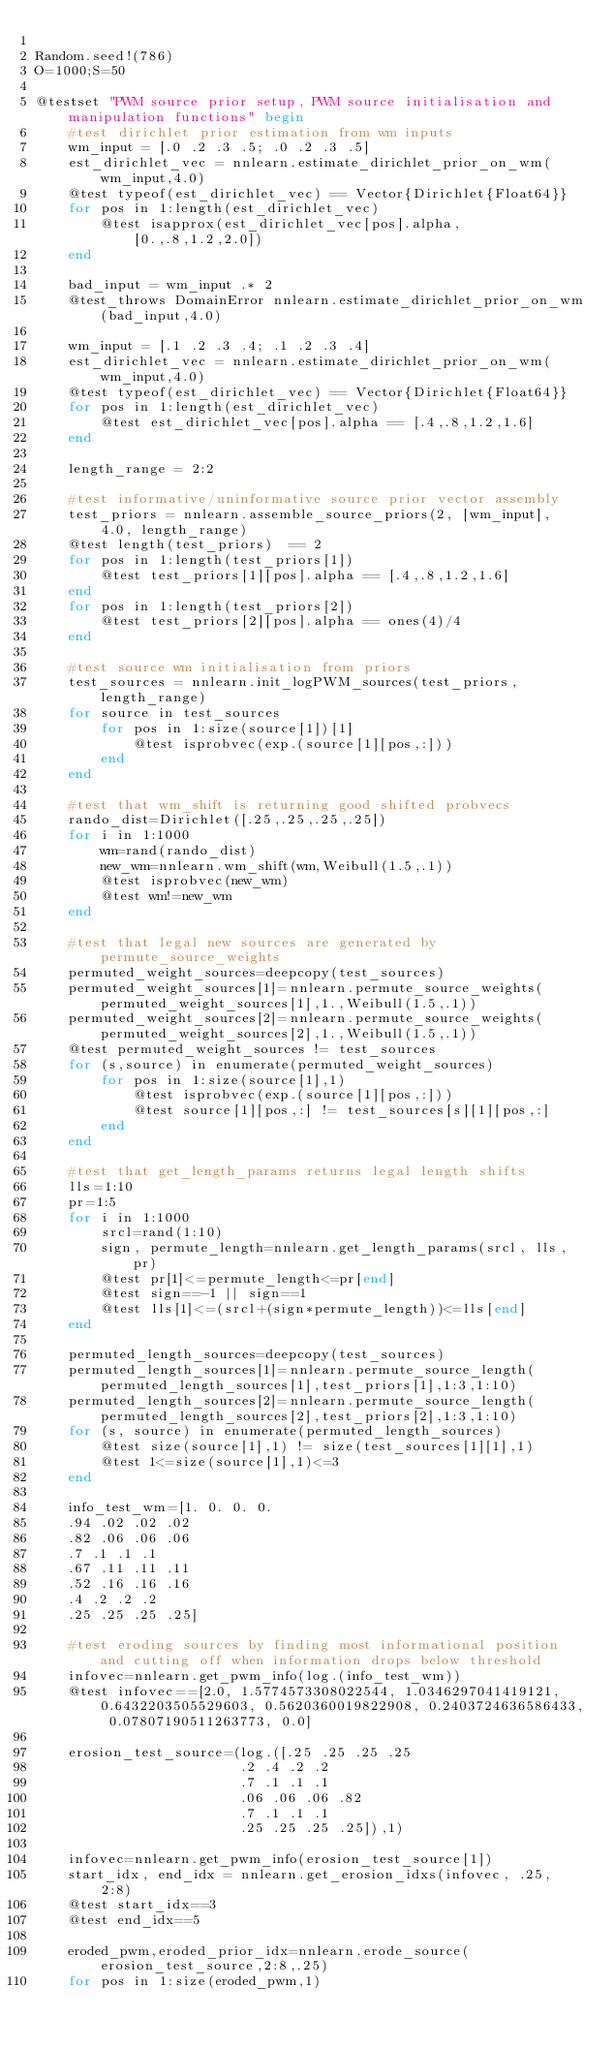<code> <loc_0><loc_0><loc_500><loc_500><_Julia_>
Random.seed!(786)
O=1000;S=50

@testset "PWM source prior setup, PWM source initialisation and manipulation functions" begin
    #test dirichlet prior estimation from wm inputs
    wm_input = [.0 .2 .3 .5; .0 .2 .3 .5]
    est_dirichlet_vec = nnlearn.estimate_dirichlet_prior_on_wm(wm_input,4.0)
    @test typeof(est_dirichlet_vec) == Vector{Dirichlet{Float64}}
    for pos in 1:length(est_dirichlet_vec)
        @test isapprox(est_dirichlet_vec[pos].alpha, [0.,.8,1.2,2.0])
    end

    bad_input = wm_input .* 2
    @test_throws DomainError nnlearn.estimate_dirichlet_prior_on_wm(bad_input,4.0)

    wm_input = [.1 .2 .3 .4; .1 .2 .3 .4]
    est_dirichlet_vec = nnlearn.estimate_dirichlet_prior_on_wm(wm_input,4.0)
    @test typeof(est_dirichlet_vec) == Vector{Dirichlet{Float64}}
    for pos in 1:length(est_dirichlet_vec)
        @test est_dirichlet_vec[pos].alpha == [.4,.8,1.2,1.6]
    end

    length_range = 2:2

    #test informative/uninformative source prior vector assembly
    test_priors = nnlearn.assemble_source_priors(2, [wm_input], 4.0, length_range)
    @test length(test_priors)  == 2
    for pos in 1:length(test_priors[1])
        @test test_priors[1][pos].alpha == [.4,.8,1.2,1.6]
    end
    for pos in 1:length(test_priors[2])
        @test test_priors[2][pos].alpha == ones(4)/4
    end

    #test source wm initialisation from priors
    test_sources = nnlearn.init_logPWM_sources(test_priors, length_range)
    for source in test_sources
        for pos in 1:size(source[1])[1]
            @test isprobvec(exp.(source[1][pos,:]))
        end
    end

    #test that wm_shift is returning good shifted probvecs
    rando_dist=Dirichlet([.25,.25,.25,.25])
    for i in 1:1000
        wm=rand(rando_dist)
        new_wm=nnlearn.wm_shift(wm,Weibull(1.5,.1))
        @test isprobvec(new_wm)
        @test wm!=new_wm
    end

    #test that legal new sources are generated by permute_source_weights
    permuted_weight_sources=deepcopy(test_sources)
    permuted_weight_sources[1]=nnlearn.permute_source_weights(permuted_weight_sources[1],1.,Weibull(1.5,.1))
    permuted_weight_sources[2]=nnlearn.permute_source_weights(permuted_weight_sources[2],1.,Weibull(1.5,.1))
    @test permuted_weight_sources != test_sources
    for (s,source) in enumerate(permuted_weight_sources)
        for pos in 1:size(source[1],1)
            @test isprobvec(exp.(source[1][pos,:]))
            @test source[1][pos,:] != test_sources[s][1][pos,:]
        end
    end

    #test that get_length_params returns legal length shifts
    lls=1:10
    pr=1:5
    for i in 1:1000
        srcl=rand(1:10)
        sign, permute_length=nnlearn.get_length_params(srcl, lls, pr)
        @test pr[1]<=permute_length<=pr[end]
        @test sign==-1 || sign==1
        @test lls[1]<=(srcl+(sign*permute_length))<=lls[end]
    end

    permuted_length_sources=deepcopy(test_sources)
    permuted_length_sources[1]=nnlearn.permute_source_length(permuted_length_sources[1],test_priors[1],1:3,1:10)
    permuted_length_sources[2]=nnlearn.permute_source_length(permuted_length_sources[2],test_priors[2],1:3,1:10)
    for (s, source) in enumerate(permuted_length_sources)
        @test size(source[1],1) != size(test_sources[1][1],1)
        @test 1<=size(source[1],1)<=3
    end

    info_test_wm=[1. 0. 0. 0.
    .94 .02 .02 .02
    .82 .06 .06 .06
    .7 .1 .1 .1
    .67 .11 .11 .11
    .52 .16 .16 .16
    .4 .2 .2 .2
    .25 .25 .25 .25]

    #test eroding sources by finding most informational position and cutting off when information drops below threshold
    infovec=nnlearn.get_pwm_info(log.(info_test_wm))
    @test infovec==[2.0, 1.5774573308022544, 1.0346297041419121, 0.6432203505529603, 0.5620360019822908, 0.2403724636586433, 0.07807190511263773, 0.0]

    erosion_test_source=(log.([.25 .25 .25 .25
                         .2 .4 .2 .2
                         .7 .1 .1 .1
                         .06 .06 .06 .82
                         .7 .1 .1 .1
                         .25 .25 .25 .25]),1)

    infovec=nnlearn.get_pwm_info(erosion_test_source[1])
    start_idx, end_idx = nnlearn.get_erosion_idxs(infovec, .25, 2:8)
    @test start_idx==3
    @test end_idx==5

    eroded_pwm,eroded_prior_idx=nnlearn.erode_source(erosion_test_source,2:8,.25)
    for pos in 1:size(eroded_pwm,1)</code> 